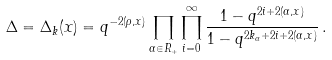<formula> <loc_0><loc_0><loc_500><loc_500>\Delta = \Delta _ { k } ( x ) = q ^ { - 2 ( \rho , x ) } \prod _ { \alpha \in R _ { + } } \prod _ { i = 0 } ^ { \infty } \frac { 1 - q ^ { 2 i + 2 ( \alpha , x ) } } { 1 - q ^ { 2 k _ { \alpha } + 2 i + 2 ( \alpha , x ) } } \, .</formula> 